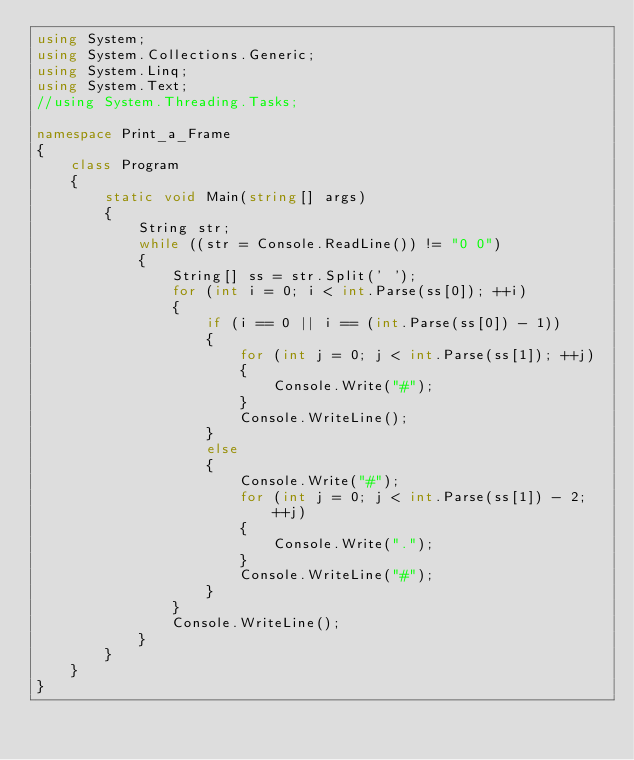<code> <loc_0><loc_0><loc_500><loc_500><_C#_>using System;
using System.Collections.Generic;
using System.Linq;
using System.Text;
//using System.Threading.Tasks;

namespace Print_a_Frame
{
    class Program
    {
        static void Main(string[] args)
        {
            String str;
            while ((str = Console.ReadLine()) != "0 0")
            {
                String[] ss = str.Split(' ');
                for (int i = 0; i < int.Parse(ss[0]); ++i)
                {
                    if (i == 0 || i == (int.Parse(ss[0]) - 1))
                    {
                        for (int j = 0; j < int.Parse(ss[1]); ++j)
                        {
                            Console.Write("#");
                        }
                        Console.WriteLine();
                    }
                    else
                    {
                        Console.Write("#");
                        for (int j = 0; j < int.Parse(ss[1]) - 2; ++j)
                        {
                            Console.Write(".");
                        }
                        Console.WriteLine("#");
                    }
                }
                Console.WriteLine();
            }
        }
    }
}
</code> 